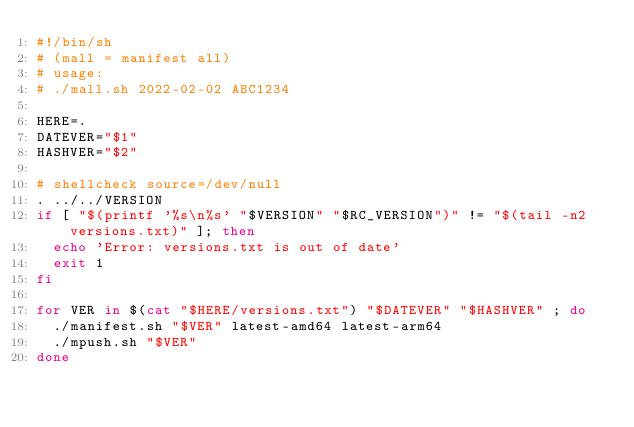Convert code to text. <code><loc_0><loc_0><loc_500><loc_500><_Bash_>#!/bin/sh
# (mall = manifest all)
# usage:
# ./mall.sh 2022-02-02 ABC1234

HERE=.
DATEVER="$1"
HASHVER="$2"

# shellcheck source=/dev/null
. ../../VERSION
if [ "$(printf '%s\n%s' "$VERSION" "$RC_VERSION")" != "$(tail -n2 versions.txt)" ]; then
  echo 'Error: versions.txt is out of date'
  exit 1
fi

for VER in $(cat "$HERE/versions.txt") "$DATEVER" "$HASHVER" ; do
  ./manifest.sh "$VER" latest-amd64 latest-arm64
  ./mpush.sh "$VER"
done
</code> 